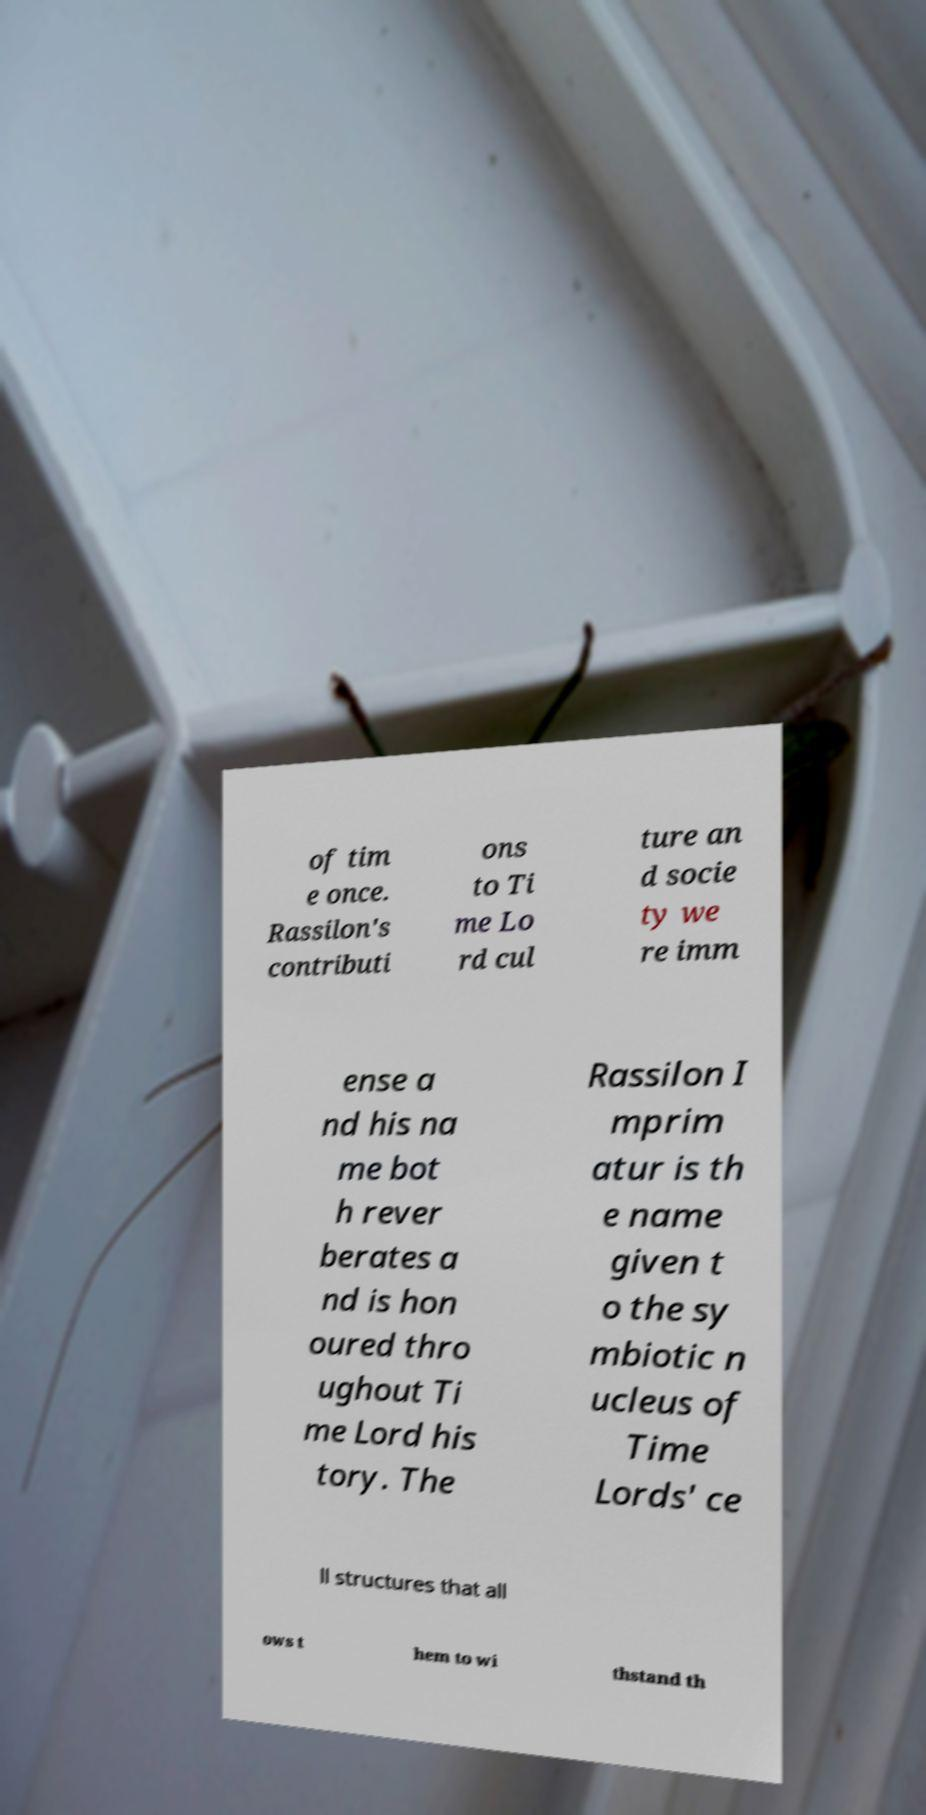There's text embedded in this image that I need extracted. Can you transcribe it verbatim? of tim e once. Rassilon's contributi ons to Ti me Lo rd cul ture an d socie ty we re imm ense a nd his na me bot h rever berates a nd is hon oured thro ughout Ti me Lord his tory. The Rassilon I mprim atur is th e name given t o the sy mbiotic n ucleus of Time Lords' ce ll structures that all ows t hem to wi thstand th 